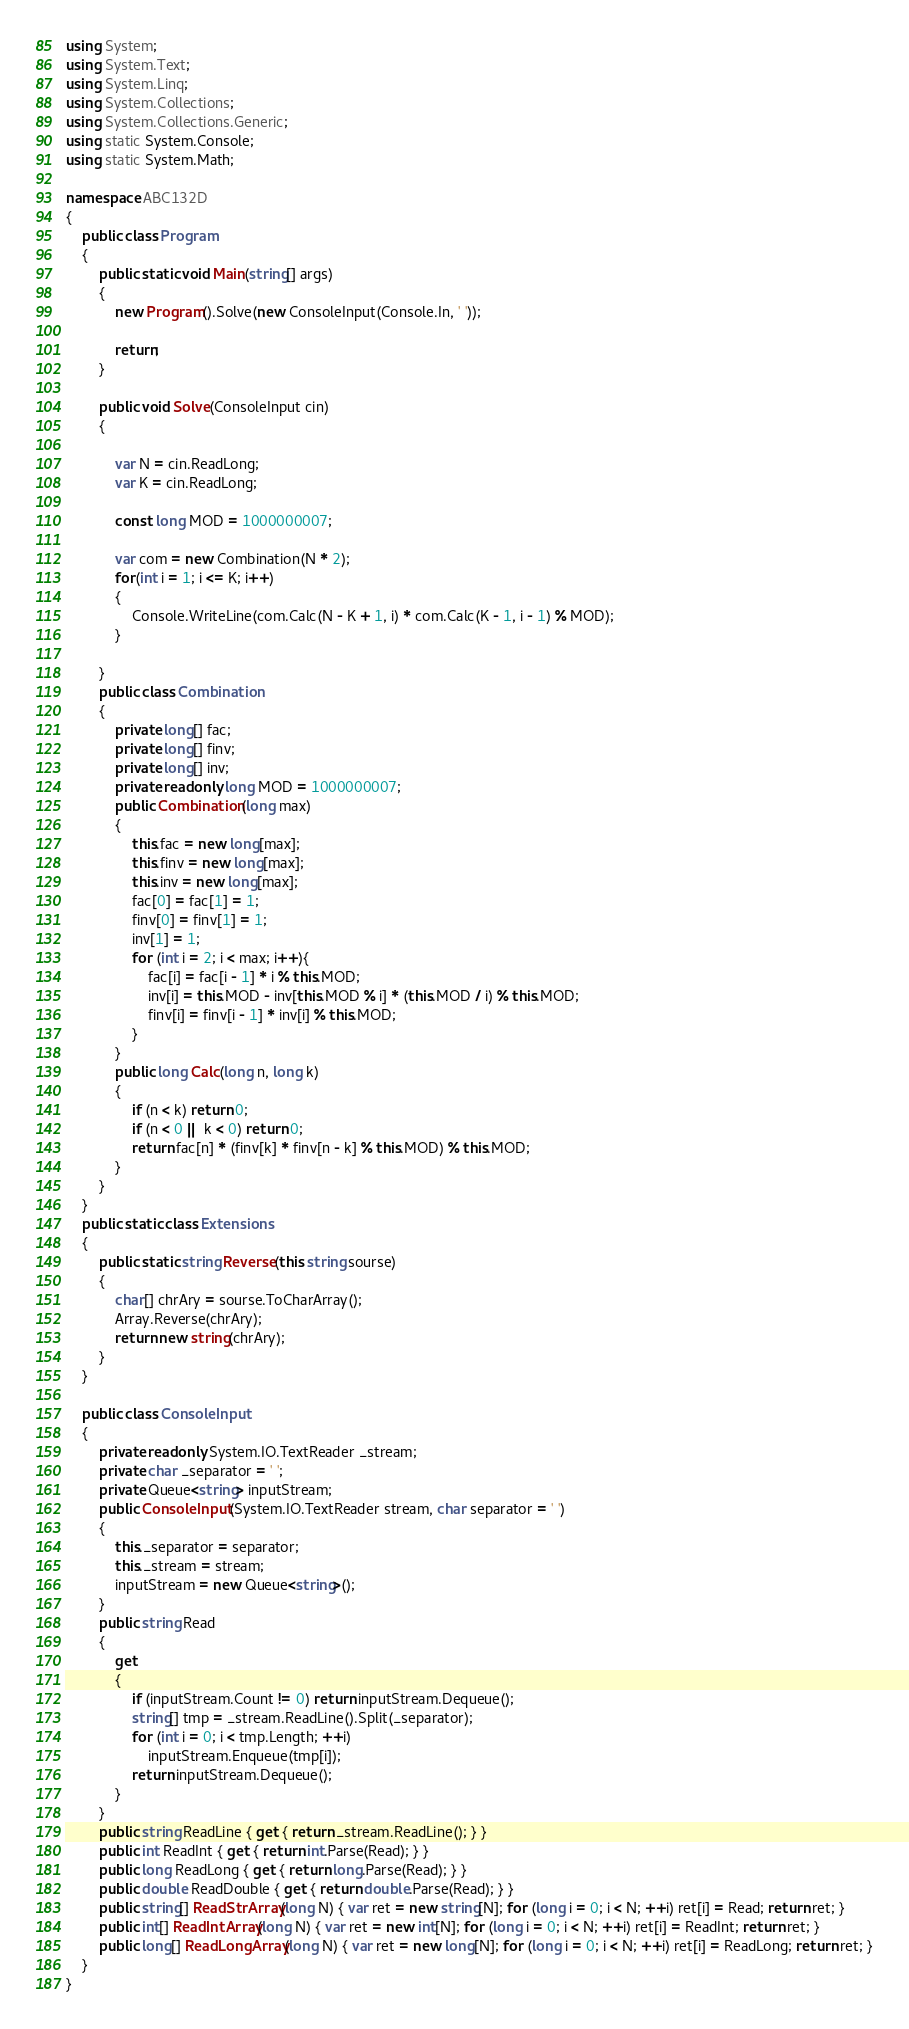<code> <loc_0><loc_0><loc_500><loc_500><_C#_>using System;
using System.Text;
using System.Linq;
using System.Collections;
using System.Collections.Generic;
using static System.Console;
using static System.Math;

namespace ABC132D
{
    public class Program
    {
        public static void Main(string[] args)
        {
            new Program().Solve(new ConsoleInput(Console.In, ' '));

            return;
        }

        public void Solve(ConsoleInput cin)
        {

            var N = cin.ReadLong;
            var K = cin.ReadLong;

            const long MOD = 1000000007;

            var com = new Combination(N * 2);
            for(int i = 1; i <= K; i++)
            {
                Console.WriteLine(com.Calc(N - K + 1, i) * com.Calc(K - 1, i - 1) % MOD);
            }

        }
        public class Combination
        {
            private long[] fac;
            private long[] finv;
            private long[] inv;
            private readonly long MOD = 1000000007;
            public Combination(long max)
            {
                this.fac = new long[max];
                this.finv = new long[max];
                this.inv = new long[max];
                fac[0] = fac[1] = 1;
                finv[0] = finv[1] = 1;
                inv[1] = 1;
                for (int i = 2; i < max; i++){
                    fac[i] = fac[i - 1] * i % this.MOD;
                    inv[i] = this.MOD - inv[this.MOD % i] * (this.MOD / i) % this.MOD;
                    finv[i] = finv[i - 1] * inv[i] % this.MOD;
                }
            }
            public long Calc(long n, long k)
            {
                if (n < k) return 0;
                if (n < 0 || k < 0) return 0;
                return fac[n] * (finv[k] * finv[n - k] % this.MOD) % this.MOD;
            }
        }
    }
    public static class Extensions
    {
        public static string Reverse(this string sourse)
        {
            char[] chrAry = sourse.ToCharArray();
            Array.Reverse(chrAry);
            return new string(chrAry);
        }
    }

    public class ConsoleInput
    {
        private readonly System.IO.TextReader _stream;
        private char _separator = ' ';
        private Queue<string> inputStream;
        public ConsoleInput(System.IO.TextReader stream, char separator = ' ')
        {
            this._separator = separator;
            this._stream = stream;
            inputStream = new Queue<string>();
        }
        public string Read
        {
            get
            {
                if (inputStream.Count != 0) return inputStream.Dequeue();
                string[] tmp = _stream.ReadLine().Split(_separator);
                for (int i = 0; i < tmp.Length; ++i)
                    inputStream.Enqueue(tmp[i]);
                return inputStream.Dequeue();
            }
        }
        public string ReadLine { get { return _stream.ReadLine(); } }
        public int ReadInt { get { return int.Parse(Read); } }
        public long ReadLong { get { return long.Parse(Read); } }
        public double ReadDouble { get { return double.Parse(Read); } }
        public string[] ReadStrArray(long N) { var ret = new string[N]; for (long i = 0; i < N; ++i) ret[i] = Read; return ret; }
        public int[] ReadIntArray(long N) { var ret = new int[N]; for (long i = 0; i < N; ++i) ret[i] = ReadInt; return ret; }
        public long[] ReadLongArray(long N) { var ret = new long[N]; for (long i = 0; i < N; ++i) ret[i] = ReadLong; return ret; }
    }
}
</code> 